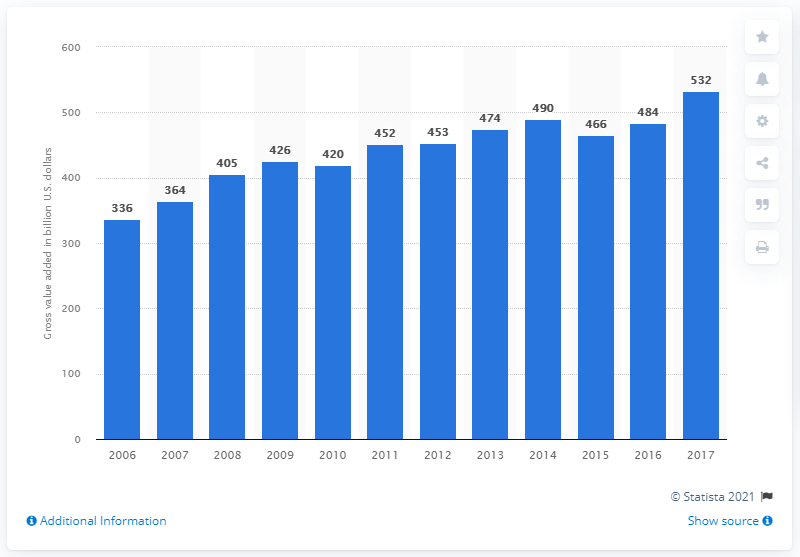Point out several critical features in this image. The gross value of the pharmaceutical industry in dollars in 2017 was 532... 